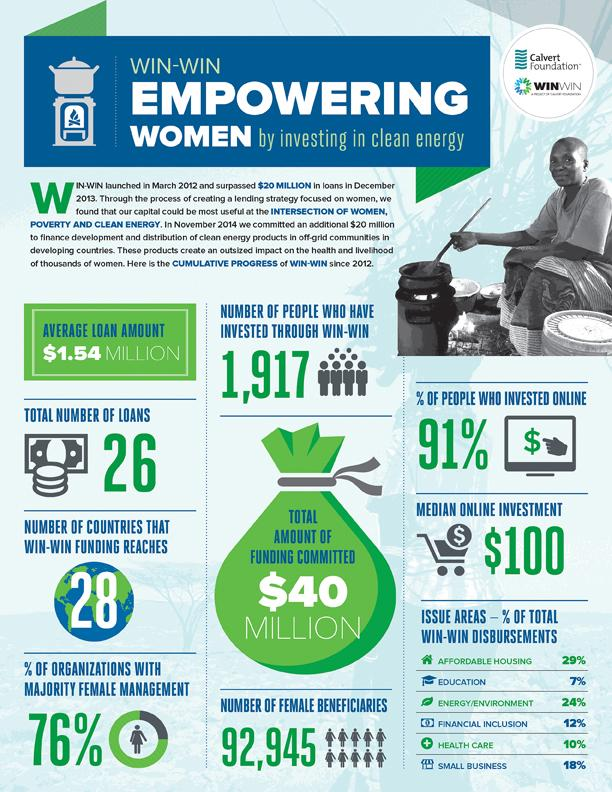Mention a couple of crucial points in this snapshot. A majority of organizations are led by women, with 76% of organizations having female management. The total amount of funding committed is $40 million. According to the data, approximately 17% of the total win-win disbursements in education and health care were allocated to these two sectors combined. 